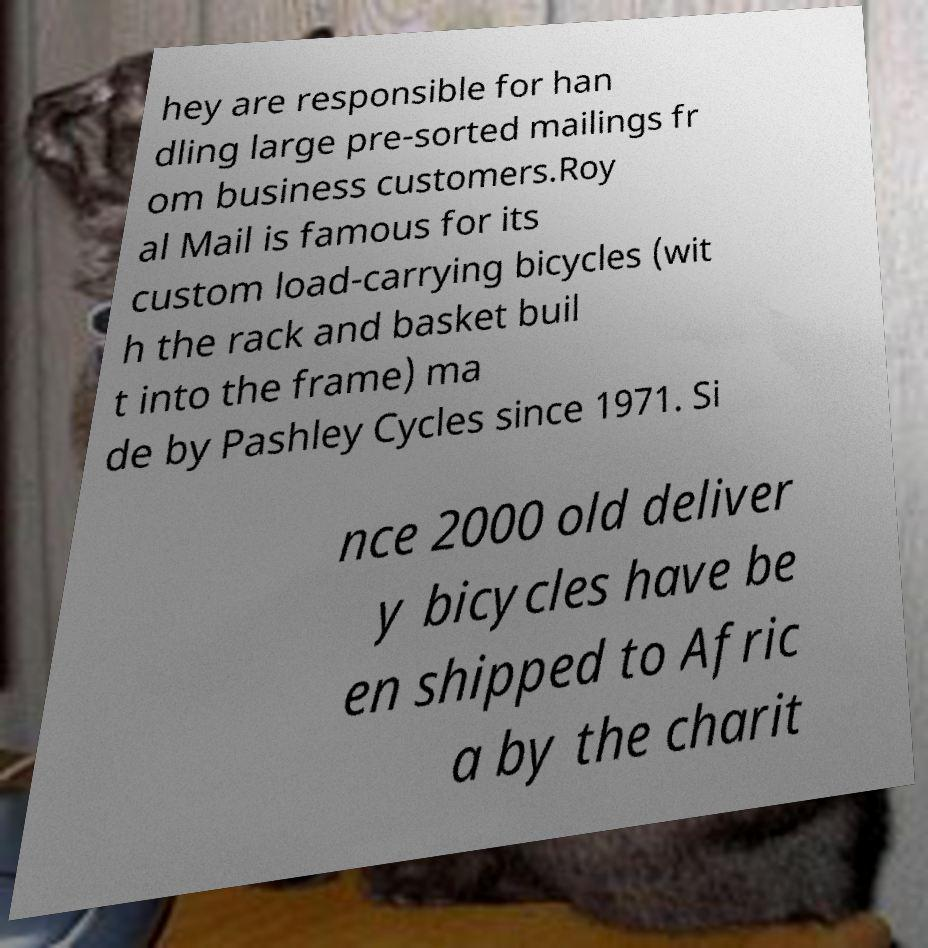Could you assist in decoding the text presented in this image and type it out clearly? hey are responsible for han dling large pre-sorted mailings fr om business customers.Roy al Mail is famous for its custom load-carrying bicycles (wit h the rack and basket buil t into the frame) ma de by Pashley Cycles since 1971. Si nce 2000 old deliver y bicycles have be en shipped to Afric a by the charit 